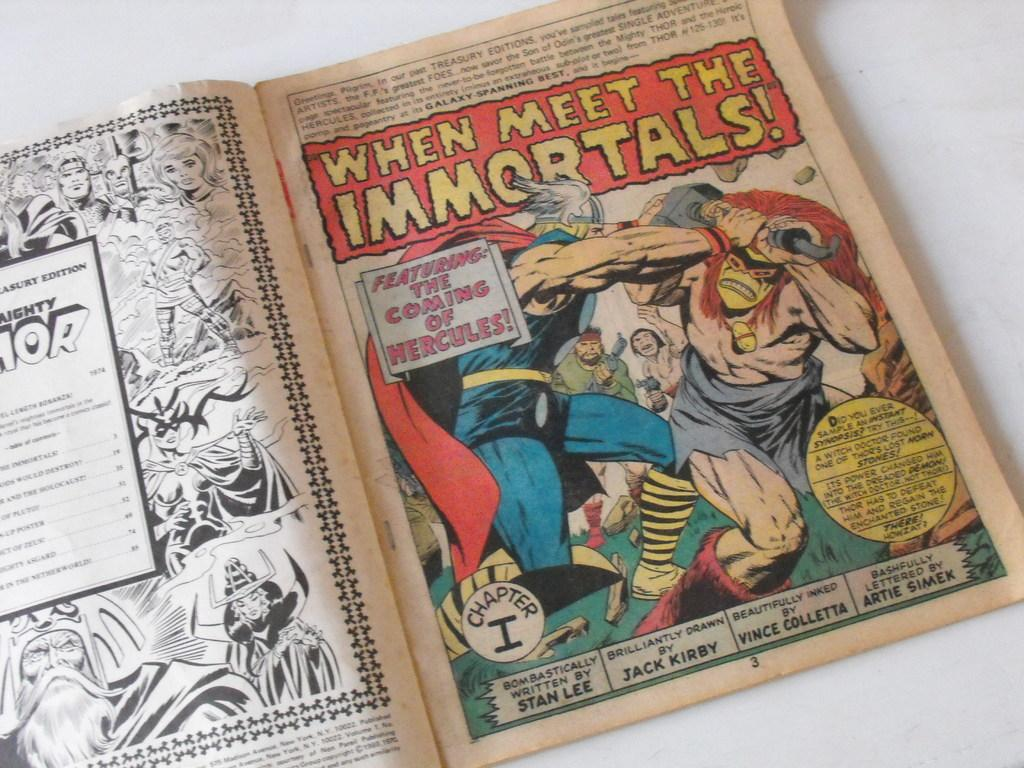<image>
Offer a succinct explanation of the picture presented. A comic which reads When Meet the Immortals. 